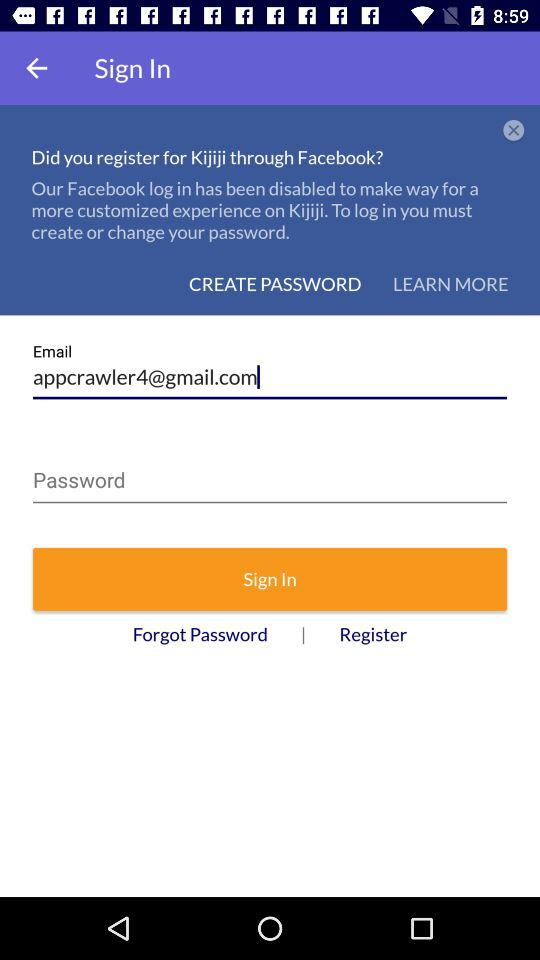Can we reset password?
When the provided information is insufficient, respond with <no answer>. <no answer> 